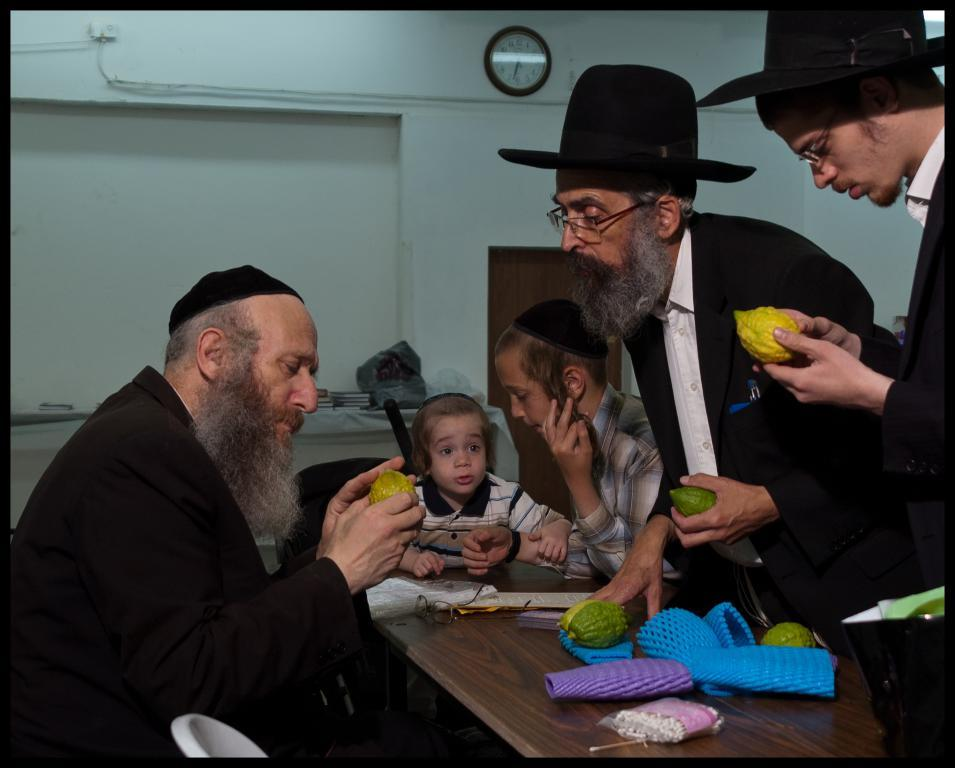Who or what is present in the image? There are people in the image. What are the people holding in the image? The people are holding fruits. Can you describe the objects on the table in the image? There are fruits on a table. What can be seen in the background of the image? There are books, a wall, and a watch in the background of the image. Are there any toys visible in the image? There is no mention of toys in the image; the people are holding fruits, and there are books, a wall, and a watch in the background. 